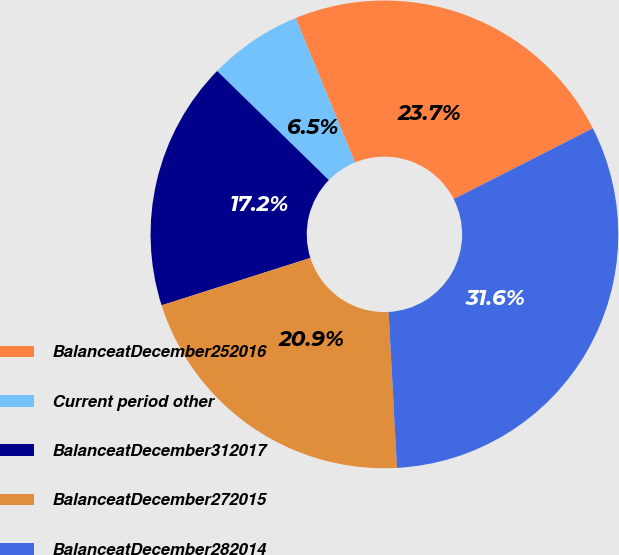Convert chart to OTSL. <chart><loc_0><loc_0><loc_500><loc_500><pie_chart><fcel>BalanceatDecember252016<fcel>Current period other<fcel>BalanceatDecember312017<fcel>BalanceatDecember272015<fcel>BalanceatDecember282014<nl><fcel>23.71%<fcel>6.49%<fcel>17.22%<fcel>20.95%<fcel>31.64%<nl></chart> 